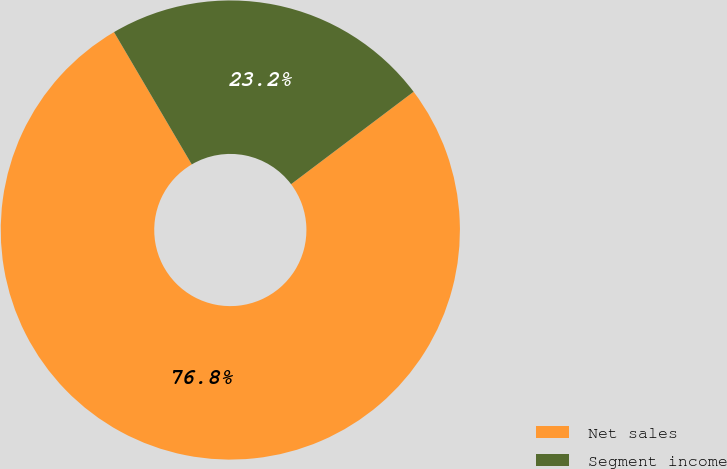<chart> <loc_0><loc_0><loc_500><loc_500><pie_chart><fcel>Net sales<fcel>Segment income<nl><fcel>76.83%<fcel>23.17%<nl></chart> 